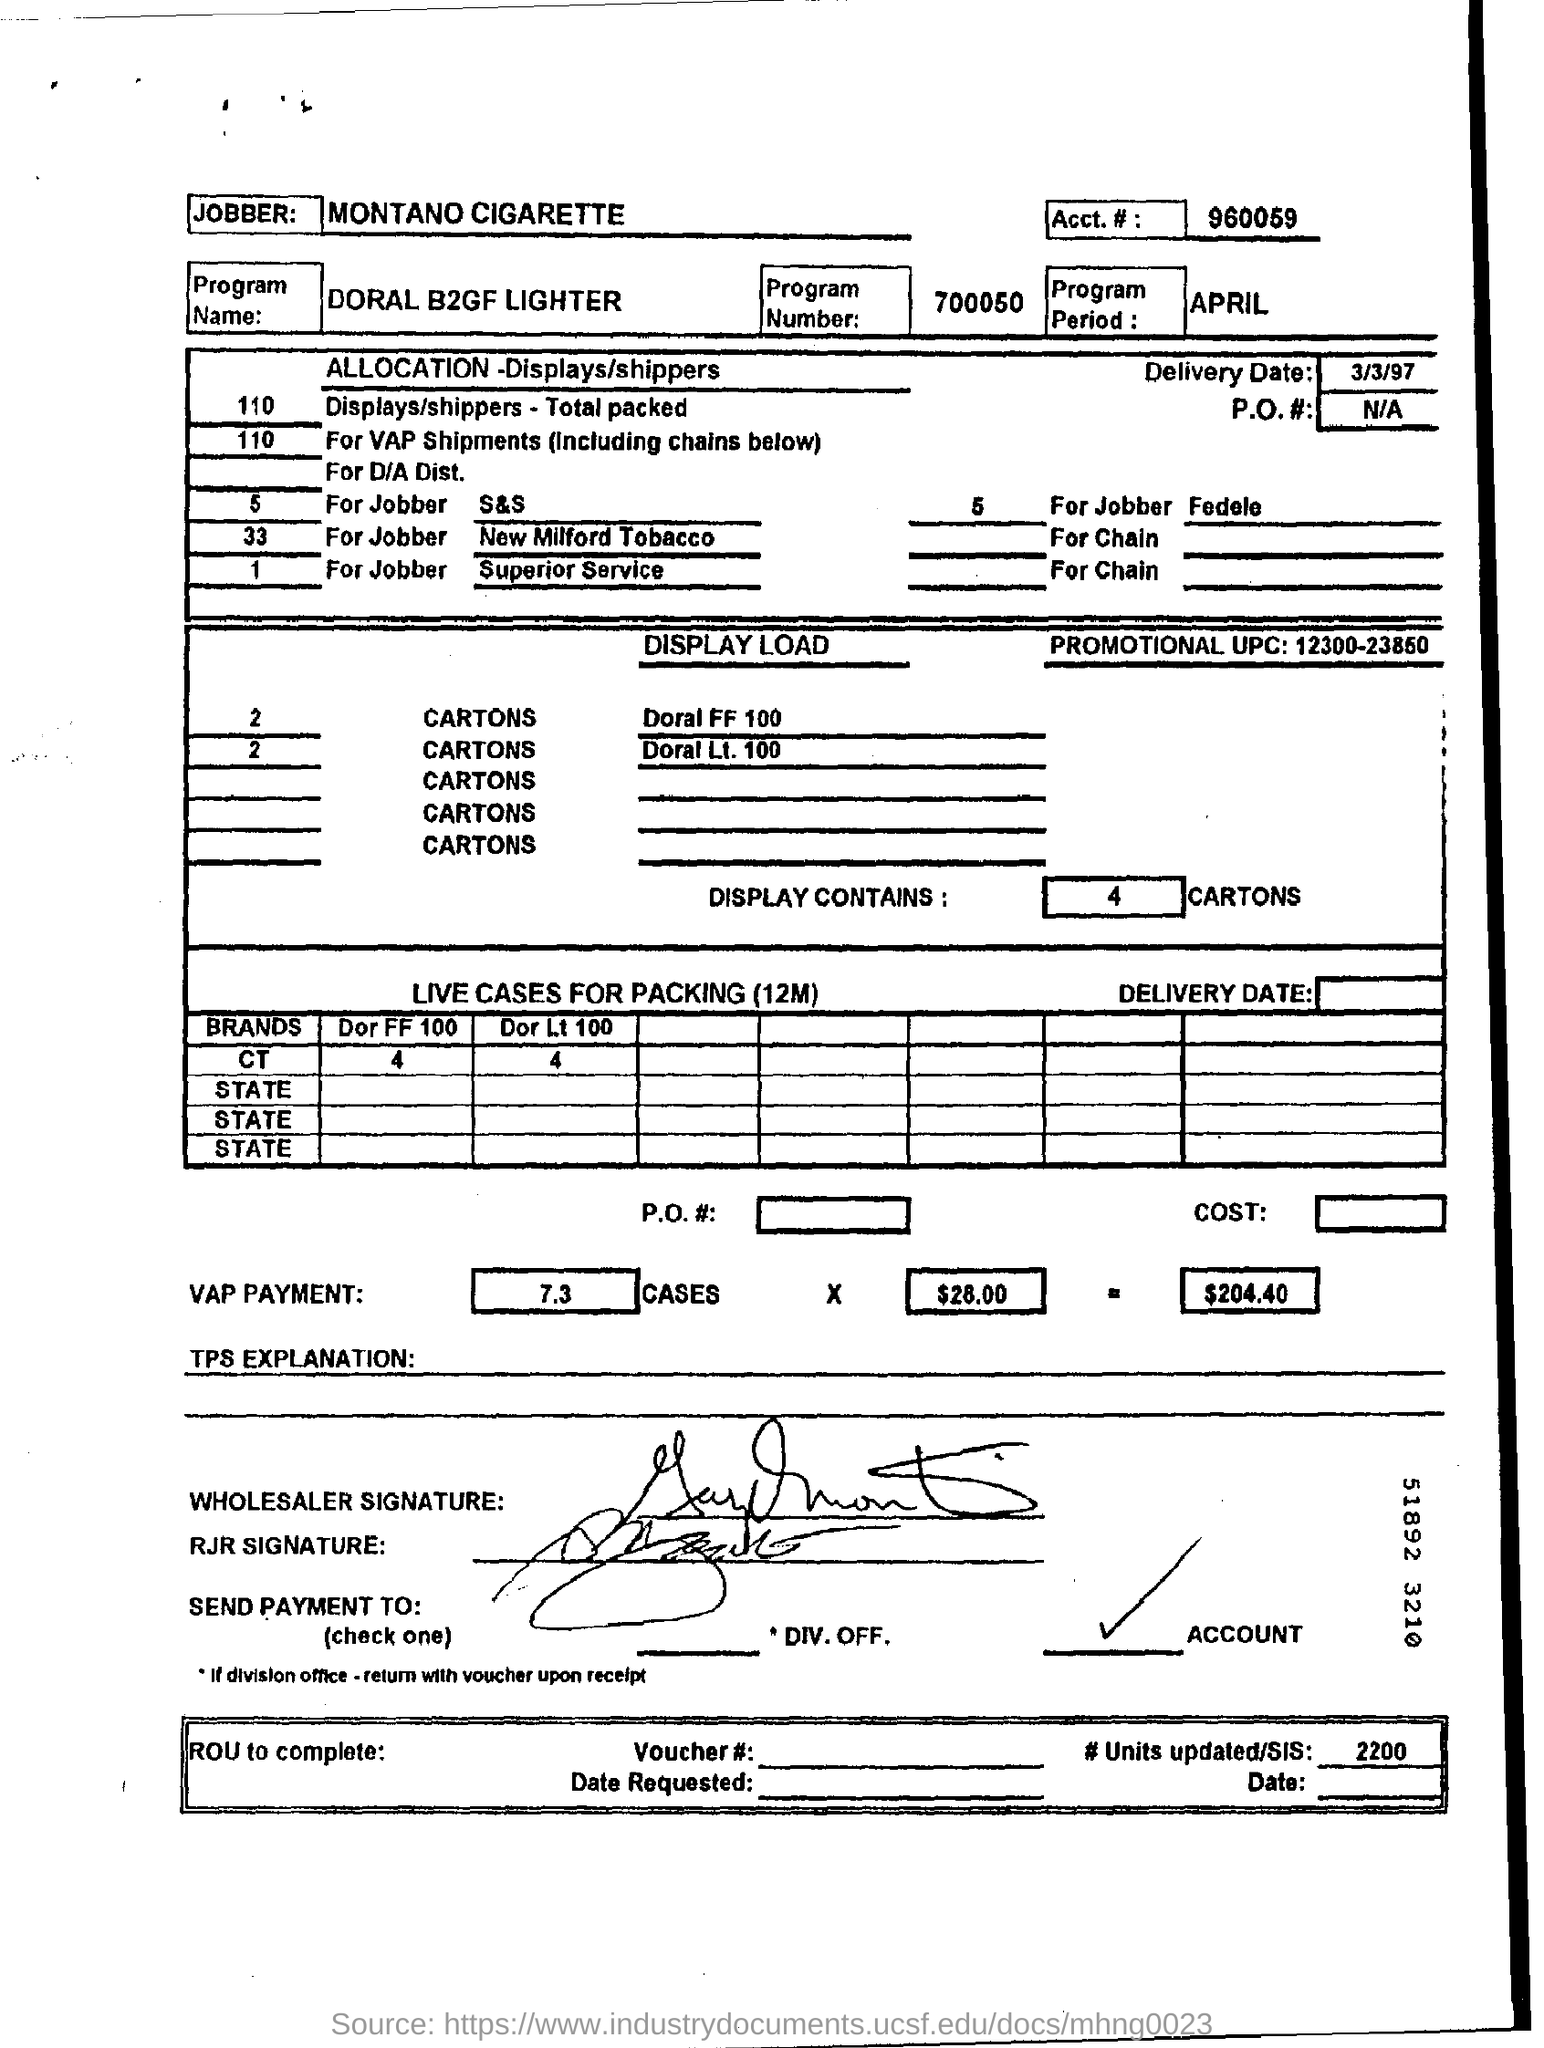How many cartons does display contains ?
Your answer should be very brief. 4. What is the program period ?
Your response must be concise. APRIL. What is the name of the program ?
Your answer should be very brief. Doral b2gf lighter. Mention the delivery date ?
Ensure brevity in your answer.  3/3/97. 